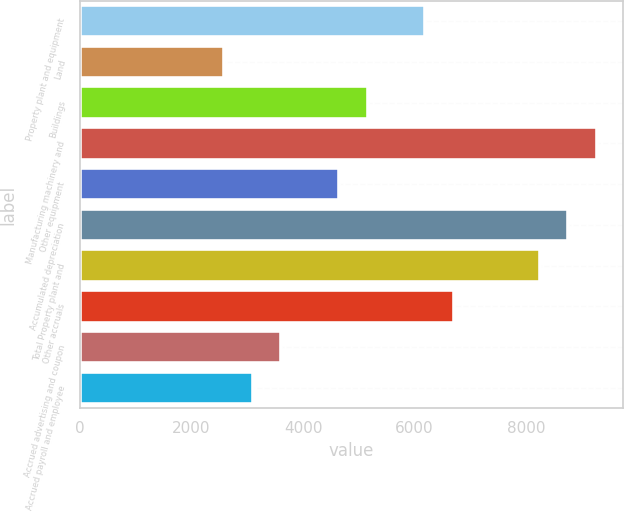Convert chart to OTSL. <chart><loc_0><loc_0><loc_500><loc_500><bar_chart><fcel>Property plant and equipment<fcel>Land<fcel>Buildings<fcel>Manufacturing machinery and<fcel>Other equipment<fcel>Accumulated depreciation<fcel>Total Property plant and<fcel>Other accruals<fcel>Accrued advertising and coupon<fcel>Accrued payroll and employee<nl><fcel>6186.6<fcel>2583<fcel>5157<fcel>9275.4<fcel>4642.2<fcel>8760.6<fcel>8245.8<fcel>6701.4<fcel>3612.6<fcel>3097.8<nl></chart> 